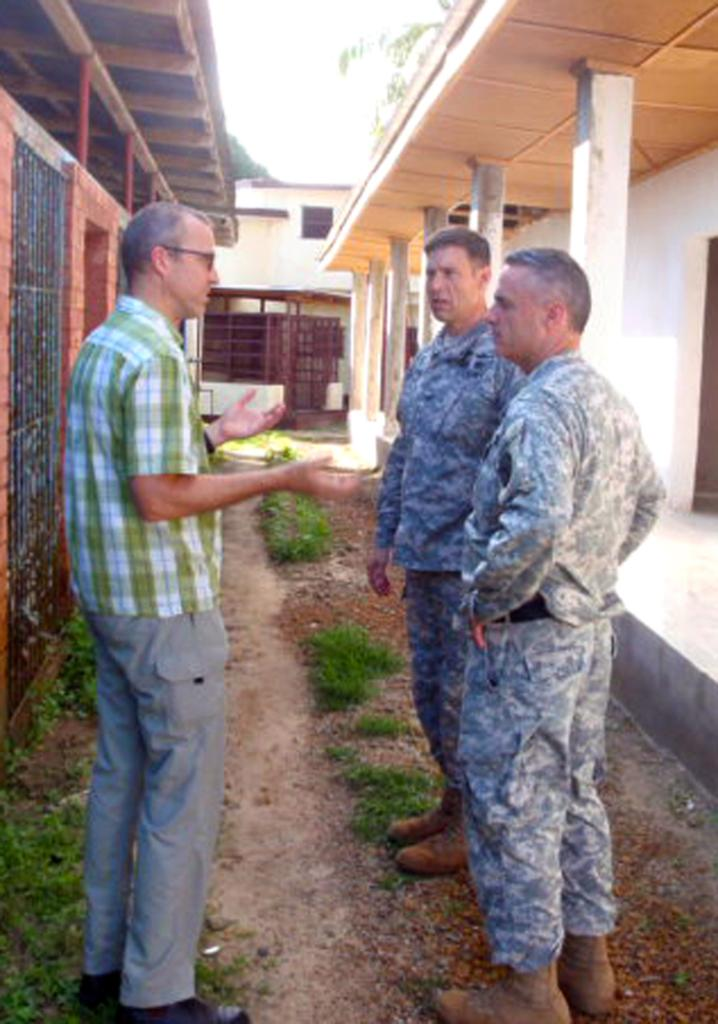How many people are in the image? There are three persons standing in the image. Are the clothes of any of the persons similar? Yes, two of the persons are wearing the same clothes. What type of structures can be seen in the image? There are buildings, pillars, and iron grilles in the image. What type of vegetation is present in the image? There is grass and trees in the image. What part of the natural environment is visible in the image? The sky is visible in the image. What type of glove is being used to cause pain in the image? There is no glove or indication of pain present in the image. What type of blade is being used to cut the trees in the image? There is no blade or tree-cutting activity depicted in the image. 